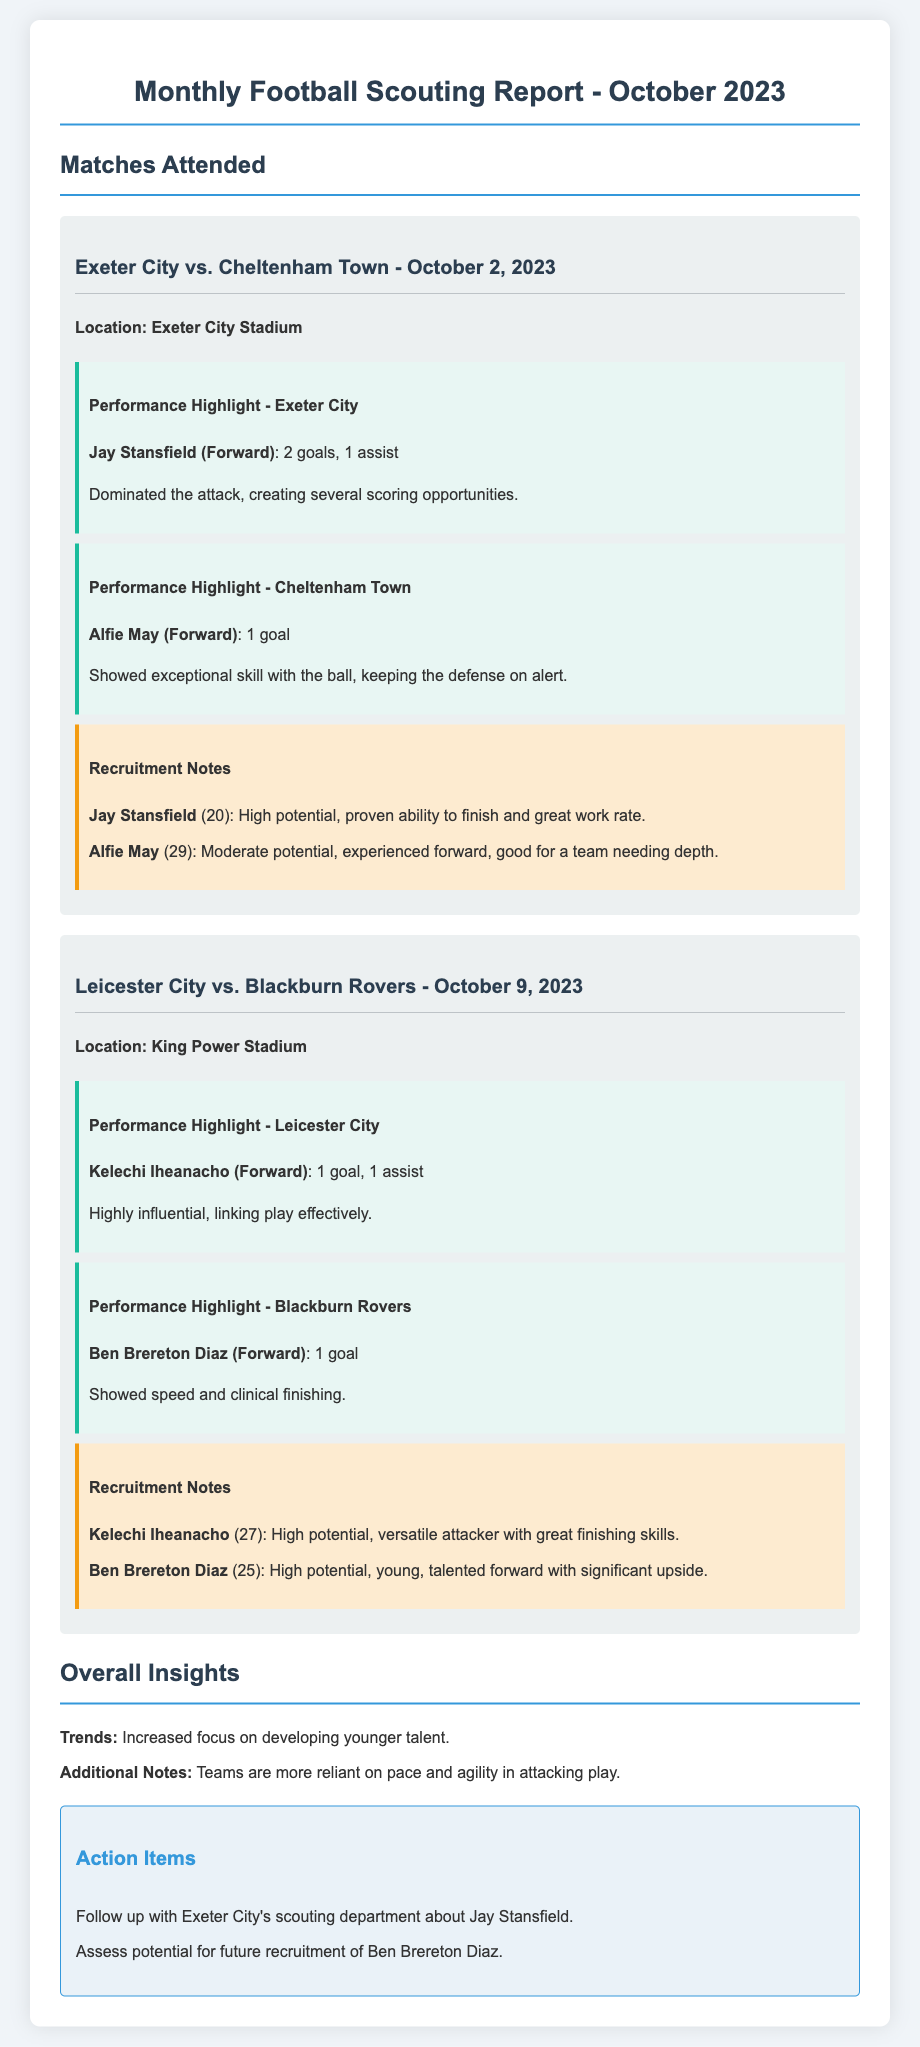What was the date of the match between Exeter City and Cheltenham Town? The date of the match is provided in the heading of that match section.
Answer: October 2, 2023 Who scored the first goal for Exeter City? The player's performance highlights indicate the players who scored, specifying the goals scored by each player.
Answer: Jay Stansfield What age is Alfie May? The age can be inferred from the recruitment notes that mention his age in parentheses.
Answer: 29 How many goals did Kelechi Iheanacho score in the Leicester City vs. Blackburn Rovers match? The performance highlights for Leicester City detail the specific contributions of players, including goals scored.
Answer: 1 goal Which team relied more on younger talent according to overall insights? The overall insights summarize the trends observed in the matches attended, indicating a focus on youth development.
Answer: Teams What is the recruitment potential noted for Ben Brereton Diaz? His potential is listed in the recruitment notes, highlighting his attributes and expected future contributions.
Answer: High potential How many assists did Jay Stansfield have? The performance highlight section for Exeter City provides explicit statistical information about player contributions.
Answer: 1 assist What is the purpose of the action items section in this report? This section specifically lists follow-up actions based on observations made during the matches, which indicates next steps for recruitment considerations.
Answer: Follow-up actions What does the recruitment note for Jay Stansfield emphasize about his work rate? The recruitment notes describe the key attributes of the players being evaluated for recruitment, which includes work ethic.
Answer: Great work rate 